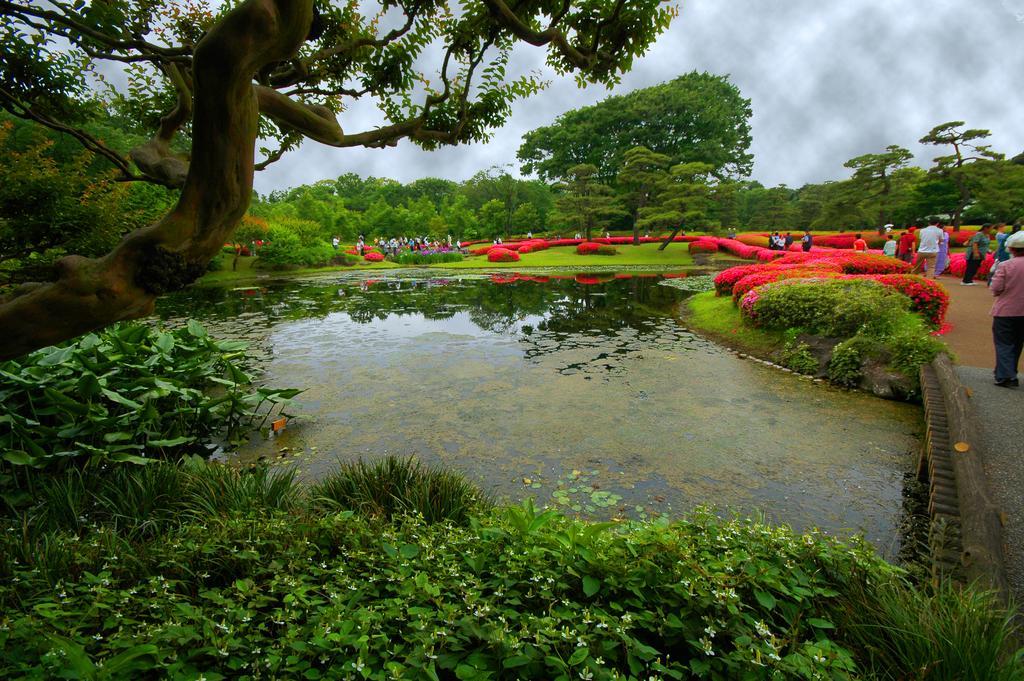Can you describe this image briefly? In this image I can see the lake , around the lake I can see plants and bushes and I can see red color bushes and trees visible in the middle , in front of bushes I can see persons, at the top I can see the sky , on the left side I can see trees. 